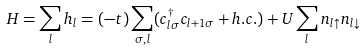Convert formula to latex. <formula><loc_0><loc_0><loc_500><loc_500>H = \sum _ { l } h _ { l } = ( - t ) \sum _ { \sigma , l } ( c _ { l \sigma } ^ { \dagger } c _ { l + 1 \sigma } + h . c . ) + U \sum _ { l } n _ { l \uparrow } n _ { l \downarrow }</formula> 